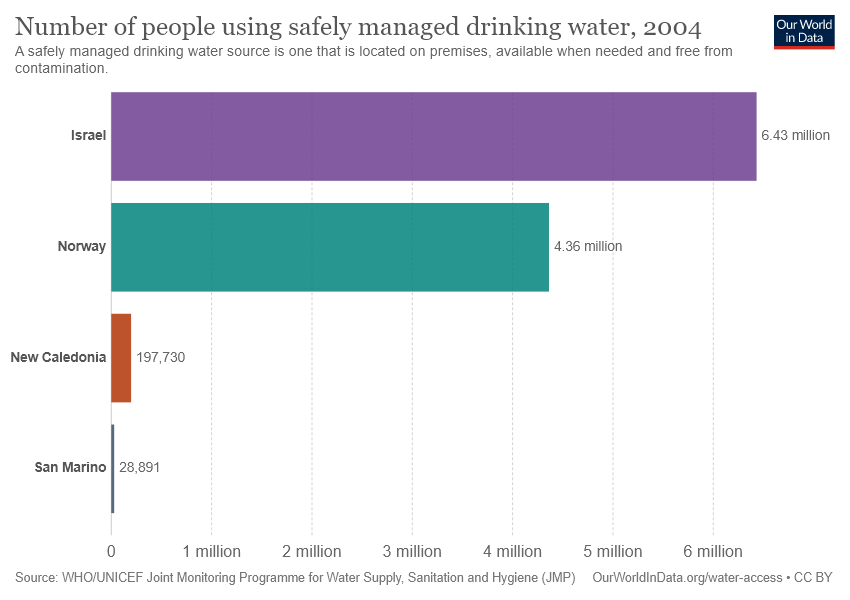Give some essential details in this illustration. The bar chart shows the value of five different places, and Israel has the highest value. The ratio of Norway and Israel in the bar chart is 1.4747706422018347... 